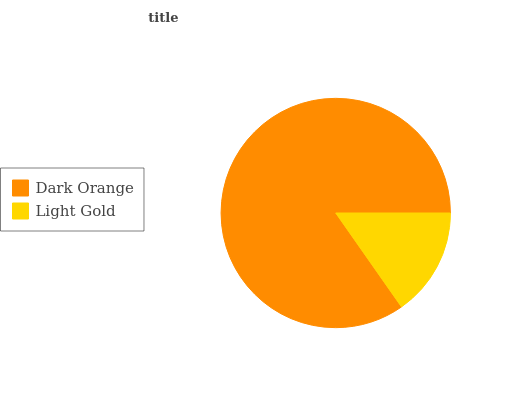Is Light Gold the minimum?
Answer yes or no. Yes. Is Dark Orange the maximum?
Answer yes or no. Yes. Is Light Gold the maximum?
Answer yes or no. No. Is Dark Orange greater than Light Gold?
Answer yes or no. Yes. Is Light Gold less than Dark Orange?
Answer yes or no. Yes. Is Light Gold greater than Dark Orange?
Answer yes or no. No. Is Dark Orange less than Light Gold?
Answer yes or no. No. Is Dark Orange the high median?
Answer yes or no. Yes. Is Light Gold the low median?
Answer yes or no. Yes. Is Light Gold the high median?
Answer yes or no. No. Is Dark Orange the low median?
Answer yes or no. No. 